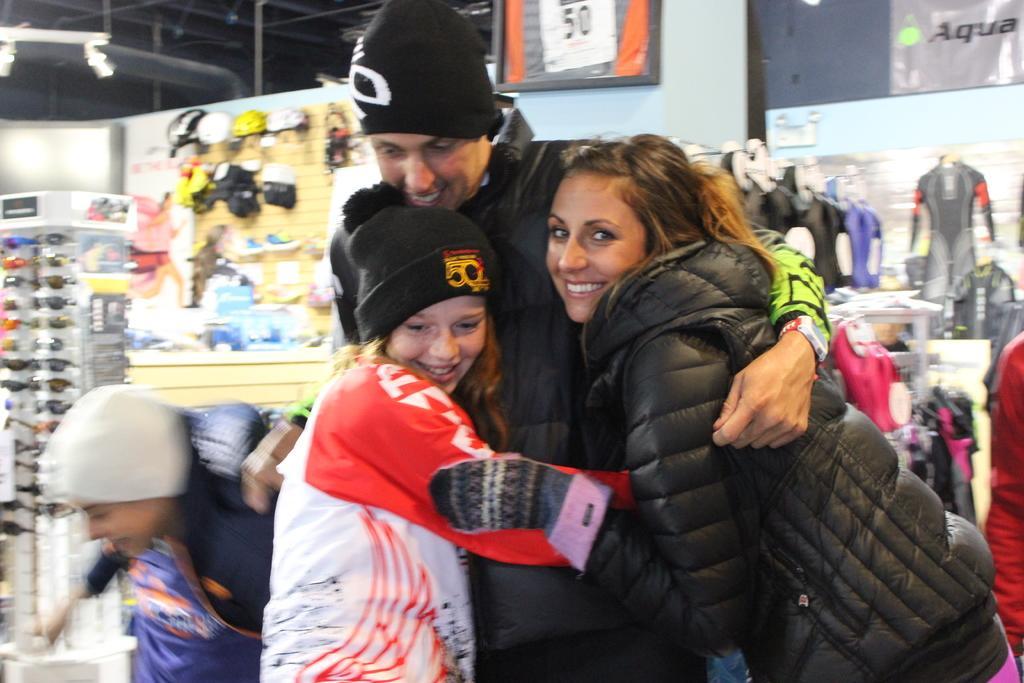In one or two sentences, can you explain what this image depicts? In this image we can see a group of people standing. On the backside we can see some glasses placed in a stand, a board with some objects on it, some shoes on a hanger, a light, some papers and a board on a wall. 